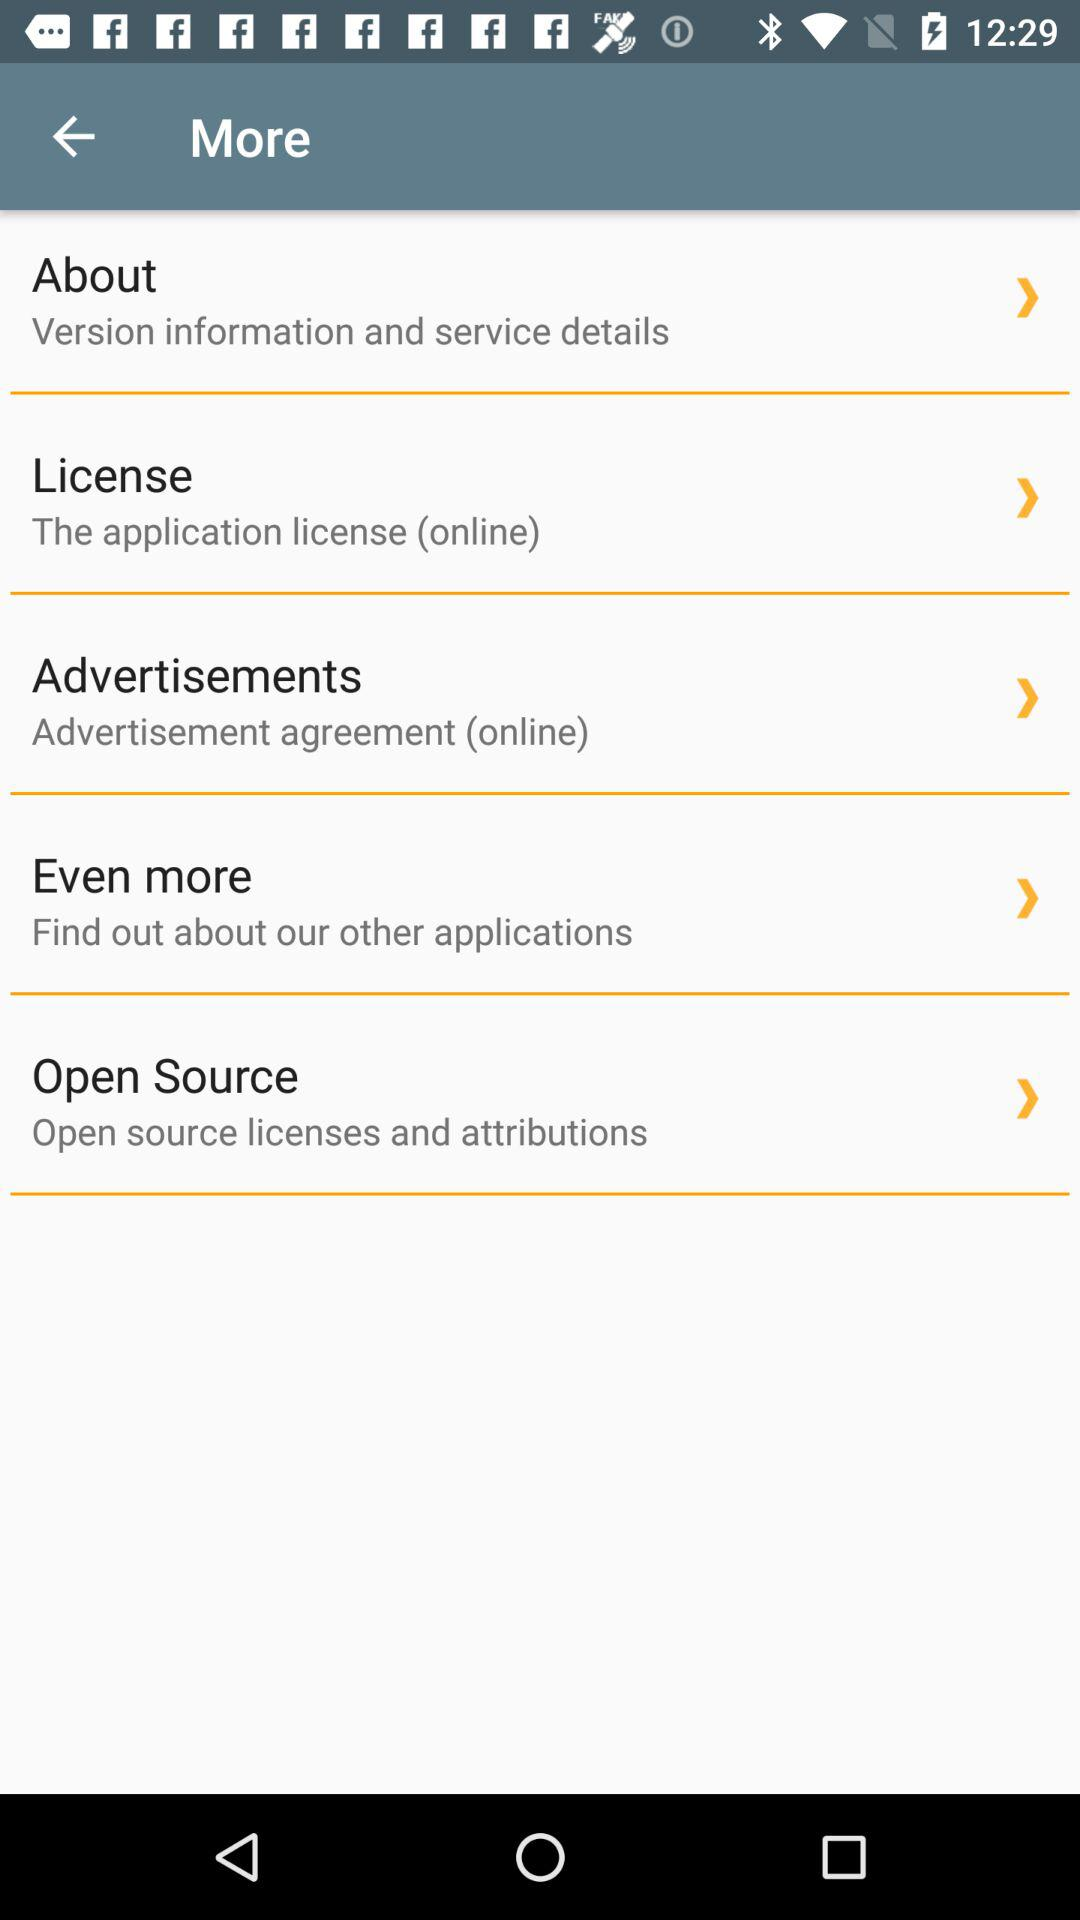How many options are there in the More menu?
Answer the question using a single word or phrase. 5 